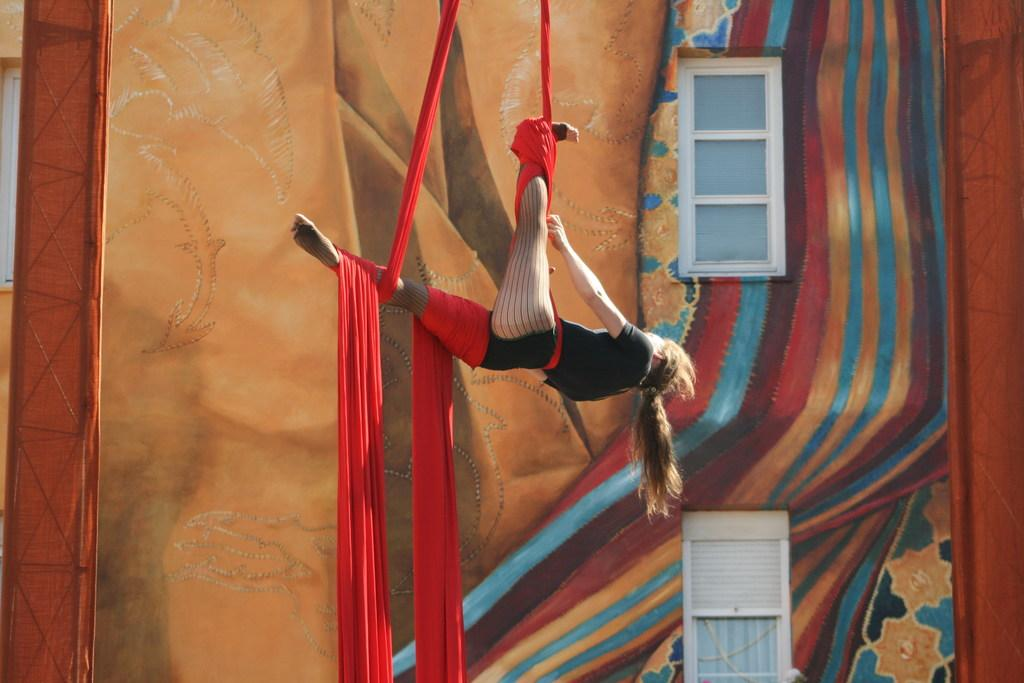Who is present in the image? There is a lady in the image. What is the lady doing in the image? The lady is hanging with a red cloth in the air. What can be seen in the background of the image? There is a wall with paintings and windows in the background. What type of beetle can be seen crawling on the lady's shoulder in the image? There is no beetle present on the lady's shoulder in the image. What hope does the lady have for the future, as depicted in the image? The image does not provide any information about the lady's hopes for the future. 